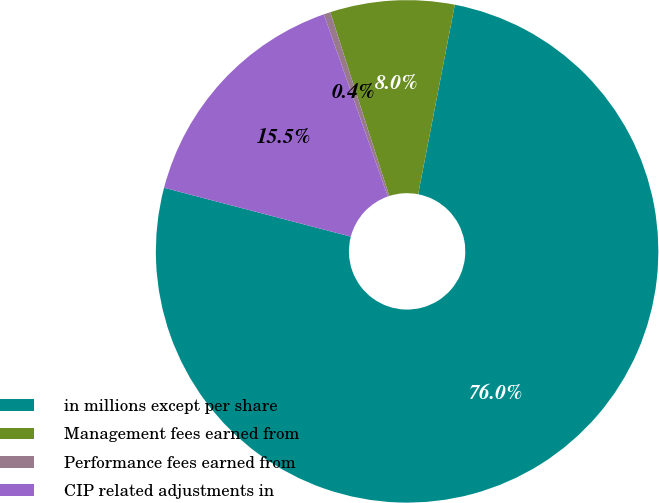Convert chart to OTSL. <chart><loc_0><loc_0><loc_500><loc_500><pie_chart><fcel>in millions except per share<fcel>Management fees earned from<fcel>Performance fees earned from<fcel>CIP related adjustments in<nl><fcel>76.04%<fcel>7.99%<fcel>0.43%<fcel>15.55%<nl></chart> 